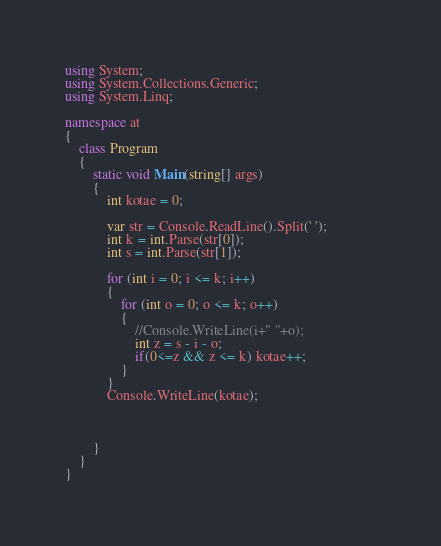<code> <loc_0><loc_0><loc_500><loc_500><_C#_>using System;
using System.Collections.Generic;
using System.Linq;
 
namespace at
{
    class Program
    {
        static void Main(string[] args)
        {
            int kotae = 0;

            var str = Console.ReadLine().Split(' ');
            int k = int.Parse(str[0]);
            int s = int.Parse(str[1]);

            for (int i = 0; i <= k; i++)
            {
                for (int o = 0; o <= k; o++)
                {
                    //Console.WriteLine(i+" "+o);
                    int z = s - i - o;
                    if(0<=z && z <= k) kotae++;                    
                }
            }
            Console.WriteLine(kotae);


            
        }        
    }
}</code> 